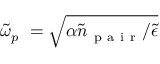Convert formula to latex. <formula><loc_0><loc_0><loc_500><loc_500>\tilde { \omega } _ { p } \ = \sqrt { \alpha \tilde { n } _ { p a i r } / \tilde { \epsilon } }</formula> 